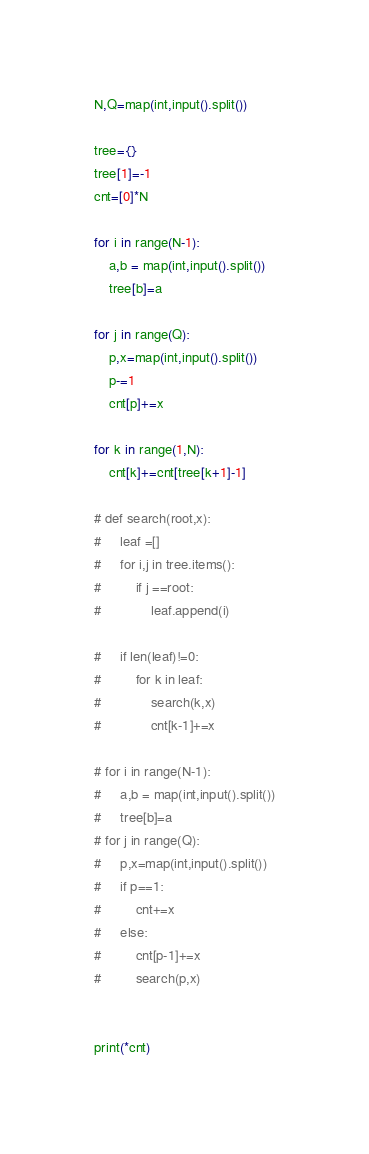Convert code to text. <code><loc_0><loc_0><loc_500><loc_500><_Python_>N,Q=map(int,input().split())

tree={}
tree[1]=-1
cnt=[0]*N

for i in range(N-1):
    a,b = map(int,input().split())
    tree[b]=a

for j in range(Q):
    p,x=map(int,input().split())
    p-=1
    cnt[p]+=x

for k in range(1,N):
    cnt[k]+=cnt[tree[k+1]-1]

# def search(root,x):
#     leaf =[]
#     for i,j in tree.items():
#         if j ==root:
#             leaf.append(i)
        
#     if len(leaf)!=0:
#         for k in leaf:
#             search(k,x)
#             cnt[k-1]+=x

# for i in range(N-1):
#     a,b = map(int,input().split())
#     tree[b]=a
# for j in range(Q):
#     p,x=map(int,input().split())
#     if p==1:
#         cnt+=x
#     else:
#         cnt[p-1]+=x
#         search(p,x)


print(*cnt)



</code> 